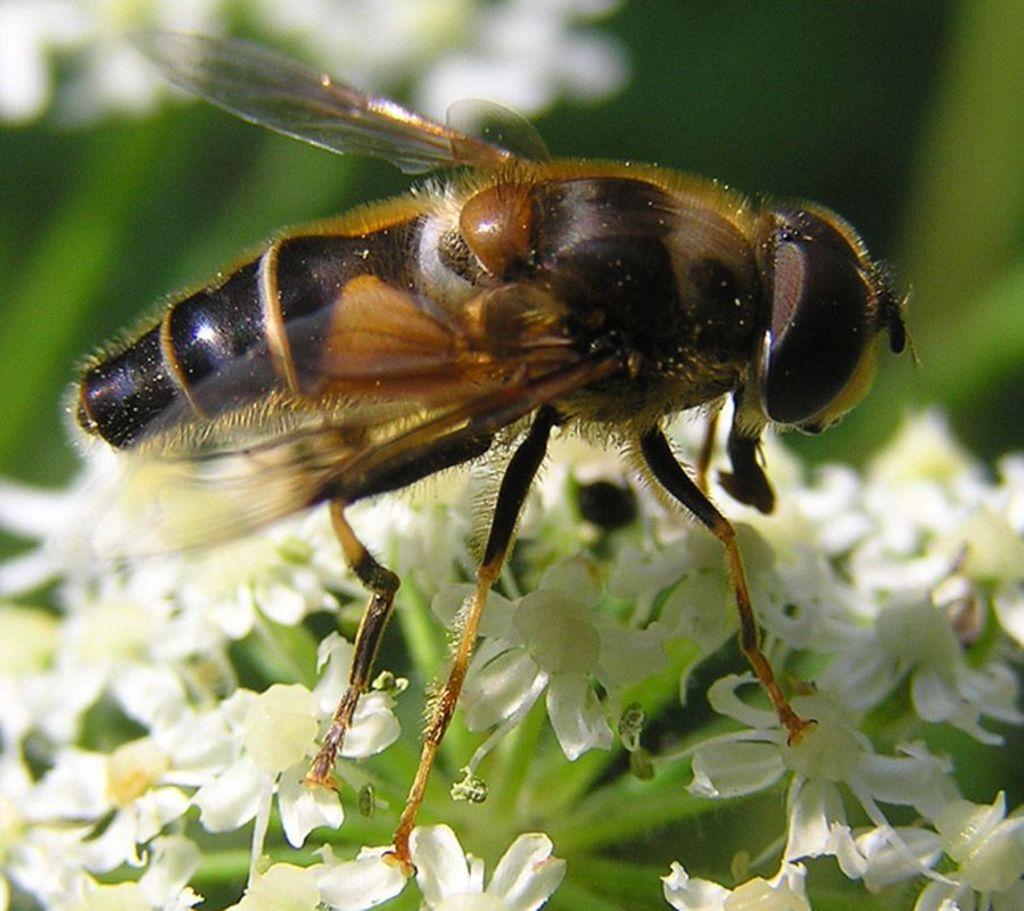What is the main subject of the picture? The main subject of the picture is an insect. Where is the insect located in the image? The insect is on flowers. Can you describe the background of the image? The background of the image is blurred. What type of shirt is the doctor wearing in the image? There is no doctor or shirt present in the image; it features an insect on flowers with a blurred background. 